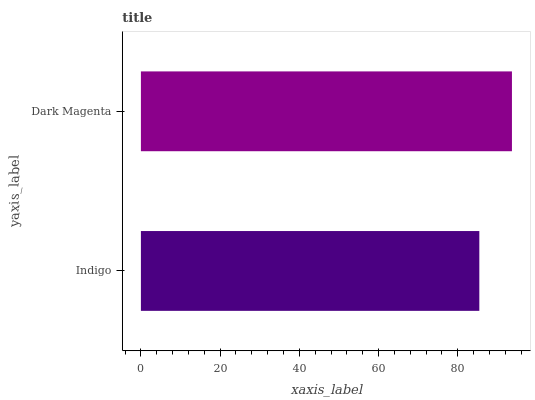Is Indigo the minimum?
Answer yes or no. Yes. Is Dark Magenta the maximum?
Answer yes or no. Yes. Is Dark Magenta the minimum?
Answer yes or no. No. Is Dark Magenta greater than Indigo?
Answer yes or no. Yes. Is Indigo less than Dark Magenta?
Answer yes or no. Yes. Is Indigo greater than Dark Magenta?
Answer yes or no. No. Is Dark Magenta less than Indigo?
Answer yes or no. No. Is Dark Magenta the high median?
Answer yes or no. Yes. Is Indigo the low median?
Answer yes or no. Yes. Is Indigo the high median?
Answer yes or no. No. Is Dark Magenta the low median?
Answer yes or no. No. 